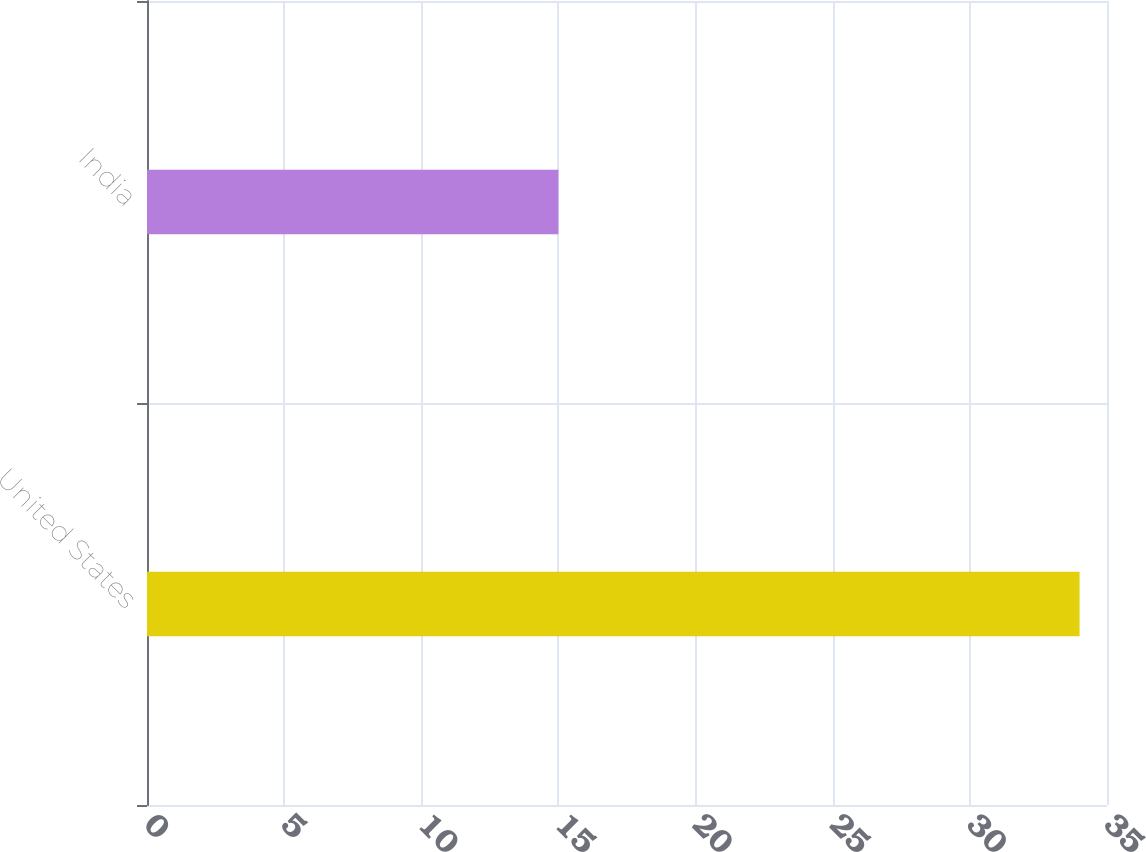<chart> <loc_0><loc_0><loc_500><loc_500><bar_chart><fcel>United States<fcel>India<nl><fcel>34<fcel>15<nl></chart> 